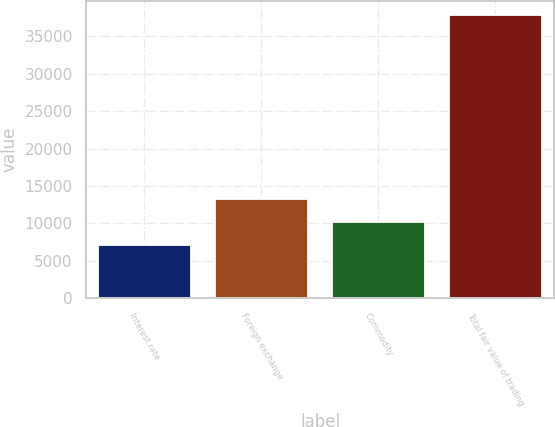<chart> <loc_0><loc_0><loc_500><loc_500><bar_chart><fcel>Interest rate<fcel>Foreign exchange<fcel>Commodity<fcel>Total fair value of trading<nl><fcel>7129<fcel>13258.6<fcel>10193.8<fcel>37777<nl></chart> 